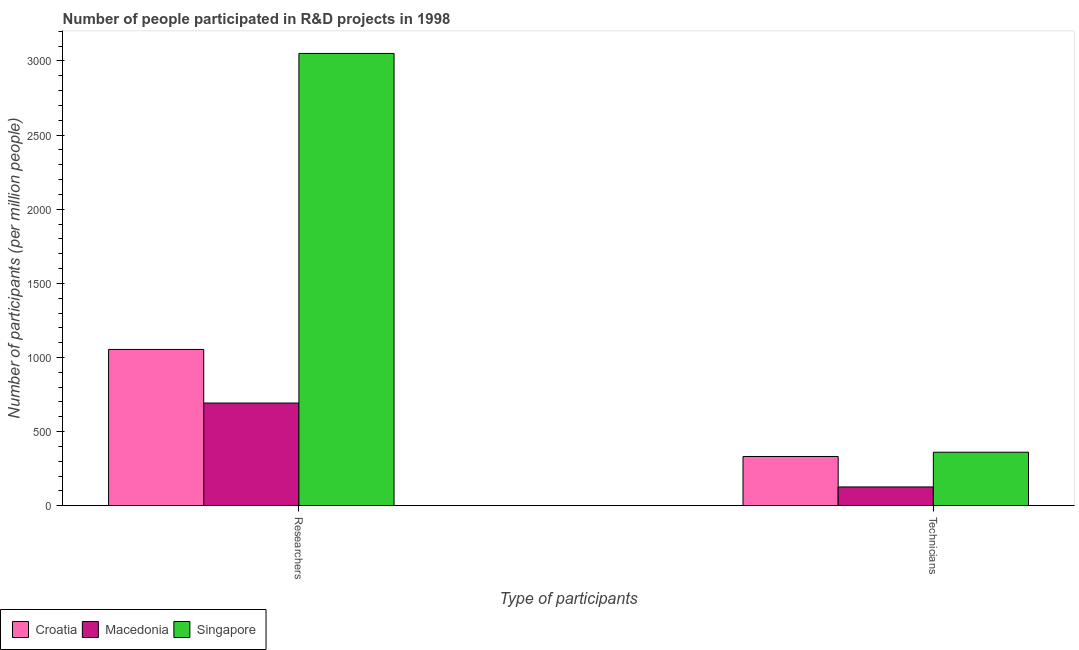How many different coloured bars are there?
Ensure brevity in your answer.  3. How many groups of bars are there?
Provide a succinct answer. 2. Are the number of bars per tick equal to the number of legend labels?
Your answer should be very brief. Yes. Are the number of bars on each tick of the X-axis equal?
Your answer should be very brief. Yes. How many bars are there on the 1st tick from the left?
Give a very brief answer. 3. How many bars are there on the 1st tick from the right?
Provide a short and direct response. 3. What is the label of the 2nd group of bars from the left?
Provide a short and direct response. Technicians. What is the number of technicians in Macedonia?
Your answer should be very brief. 127. Across all countries, what is the maximum number of researchers?
Your response must be concise. 3050.73. Across all countries, what is the minimum number of technicians?
Provide a short and direct response. 127. In which country was the number of technicians maximum?
Make the answer very short. Singapore. In which country was the number of technicians minimum?
Provide a short and direct response. Macedonia. What is the total number of researchers in the graph?
Give a very brief answer. 4798.07. What is the difference between the number of technicians in Croatia and that in Macedonia?
Ensure brevity in your answer.  205.39. What is the difference between the number of researchers in Singapore and the number of technicians in Macedonia?
Keep it short and to the point. 2923.73. What is the average number of technicians per country?
Offer a terse response. 273.51. What is the difference between the number of technicians and number of researchers in Singapore?
Ensure brevity in your answer.  -2689.58. In how many countries, is the number of researchers greater than 1800 ?
Give a very brief answer. 1. What is the ratio of the number of researchers in Singapore to that in Croatia?
Your answer should be compact. 2.89. In how many countries, is the number of technicians greater than the average number of technicians taken over all countries?
Make the answer very short. 2. What does the 3rd bar from the left in Technicians represents?
Give a very brief answer. Singapore. What does the 2nd bar from the right in Technicians represents?
Keep it short and to the point. Macedonia. How many bars are there?
Your answer should be very brief. 6. Does the graph contain grids?
Your answer should be compact. No. How are the legend labels stacked?
Provide a short and direct response. Horizontal. What is the title of the graph?
Offer a very short reply. Number of people participated in R&D projects in 1998. Does "Sri Lanka" appear as one of the legend labels in the graph?
Your answer should be compact. No. What is the label or title of the X-axis?
Provide a short and direct response. Type of participants. What is the label or title of the Y-axis?
Your response must be concise. Number of participants (per million people). What is the Number of participants (per million people) in Croatia in Researchers?
Provide a short and direct response. 1054.38. What is the Number of participants (per million people) in Macedonia in Researchers?
Offer a very short reply. 692.96. What is the Number of participants (per million people) in Singapore in Researchers?
Offer a terse response. 3050.73. What is the Number of participants (per million people) of Croatia in Technicians?
Your answer should be compact. 332.39. What is the Number of participants (per million people) in Macedonia in Technicians?
Offer a very short reply. 127. What is the Number of participants (per million people) of Singapore in Technicians?
Your answer should be compact. 361.15. Across all Type of participants, what is the maximum Number of participants (per million people) of Croatia?
Offer a terse response. 1054.38. Across all Type of participants, what is the maximum Number of participants (per million people) of Macedonia?
Provide a succinct answer. 692.96. Across all Type of participants, what is the maximum Number of participants (per million people) in Singapore?
Ensure brevity in your answer.  3050.73. Across all Type of participants, what is the minimum Number of participants (per million people) of Croatia?
Your answer should be compact. 332.39. Across all Type of participants, what is the minimum Number of participants (per million people) in Macedonia?
Make the answer very short. 127. Across all Type of participants, what is the minimum Number of participants (per million people) in Singapore?
Provide a succinct answer. 361.15. What is the total Number of participants (per million people) in Croatia in the graph?
Your answer should be compact. 1386.77. What is the total Number of participants (per million people) of Macedonia in the graph?
Your answer should be very brief. 819.96. What is the total Number of participants (per million people) in Singapore in the graph?
Provide a succinct answer. 3411.88. What is the difference between the Number of participants (per million people) in Croatia in Researchers and that in Technicians?
Provide a short and direct response. 721.99. What is the difference between the Number of participants (per million people) in Macedonia in Researchers and that in Technicians?
Your answer should be very brief. 565.96. What is the difference between the Number of participants (per million people) in Singapore in Researchers and that in Technicians?
Your answer should be very brief. 2689.58. What is the difference between the Number of participants (per million people) in Croatia in Researchers and the Number of participants (per million people) in Macedonia in Technicians?
Provide a succinct answer. 927.38. What is the difference between the Number of participants (per million people) of Croatia in Researchers and the Number of participants (per million people) of Singapore in Technicians?
Make the answer very short. 693.23. What is the difference between the Number of participants (per million people) in Macedonia in Researchers and the Number of participants (per million people) in Singapore in Technicians?
Your response must be concise. 331.81. What is the average Number of participants (per million people) in Croatia per Type of participants?
Offer a terse response. 693.38. What is the average Number of participants (per million people) of Macedonia per Type of participants?
Your answer should be compact. 409.98. What is the average Number of participants (per million people) of Singapore per Type of participants?
Ensure brevity in your answer.  1705.94. What is the difference between the Number of participants (per million people) in Croatia and Number of participants (per million people) in Macedonia in Researchers?
Ensure brevity in your answer.  361.42. What is the difference between the Number of participants (per million people) of Croatia and Number of participants (per million people) of Singapore in Researchers?
Offer a terse response. -1996.35. What is the difference between the Number of participants (per million people) in Macedonia and Number of participants (per million people) in Singapore in Researchers?
Provide a succinct answer. -2357.77. What is the difference between the Number of participants (per million people) of Croatia and Number of participants (per million people) of Macedonia in Technicians?
Give a very brief answer. 205.39. What is the difference between the Number of participants (per million people) in Croatia and Number of participants (per million people) in Singapore in Technicians?
Provide a short and direct response. -28.77. What is the difference between the Number of participants (per million people) in Macedonia and Number of participants (per million people) in Singapore in Technicians?
Ensure brevity in your answer.  -234.15. What is the ratio of the Number of participants (per million people) in Croatia in Researchers to that in Technicians?
Your answer should be compact. 3.17. What is the ratio of the Number of participants (per million people) in Macedonia in Researchers to that in Technicians?
Provide a short and direct response. 5.46. What is the ratio of the Number of participants (per million people) in Singapore in Researchers to that in Technicians?
Give a very brief answer. 8.45. What is the difference between the highest and the second highest Number of participants (per million people) of Croatia?
Ensure brevity in your answer.  721.99. What is the difference between the highest and the second highest Number of participants (per million people) of Macedonia?
Provide a succinct answer. 565.96. What is the difference between the highest and the second highest Number of participants (per million people) of Singapore?
Offer a terse response. 2689.58. What is the difference between the highest and the lowest Number of participants (per million people) in Croatia?
Keep it short and to the point. 721.99. What is the difference between the highest and the lowest Number of participants (per million people) of Macedonia?
Ensure brevity in your answer.  565.96. What is the difference between the highest and the lowest Number of participants (per million people) of Singapore?
Your response must be concise. 2689.58. 